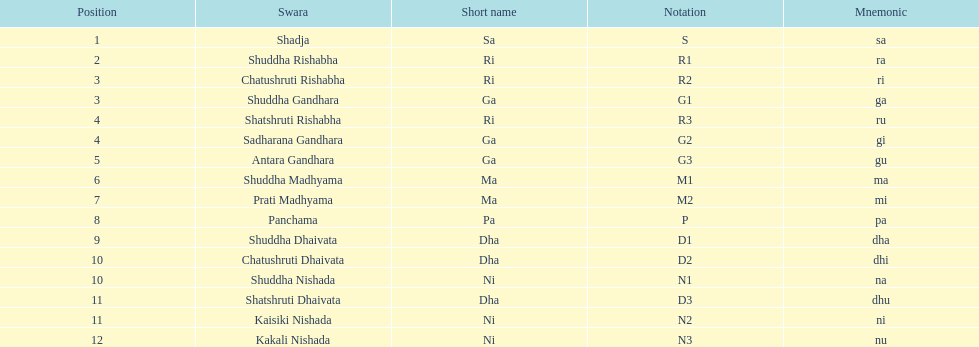What is the appellation of the swara that takes the primary position? Shadja. 